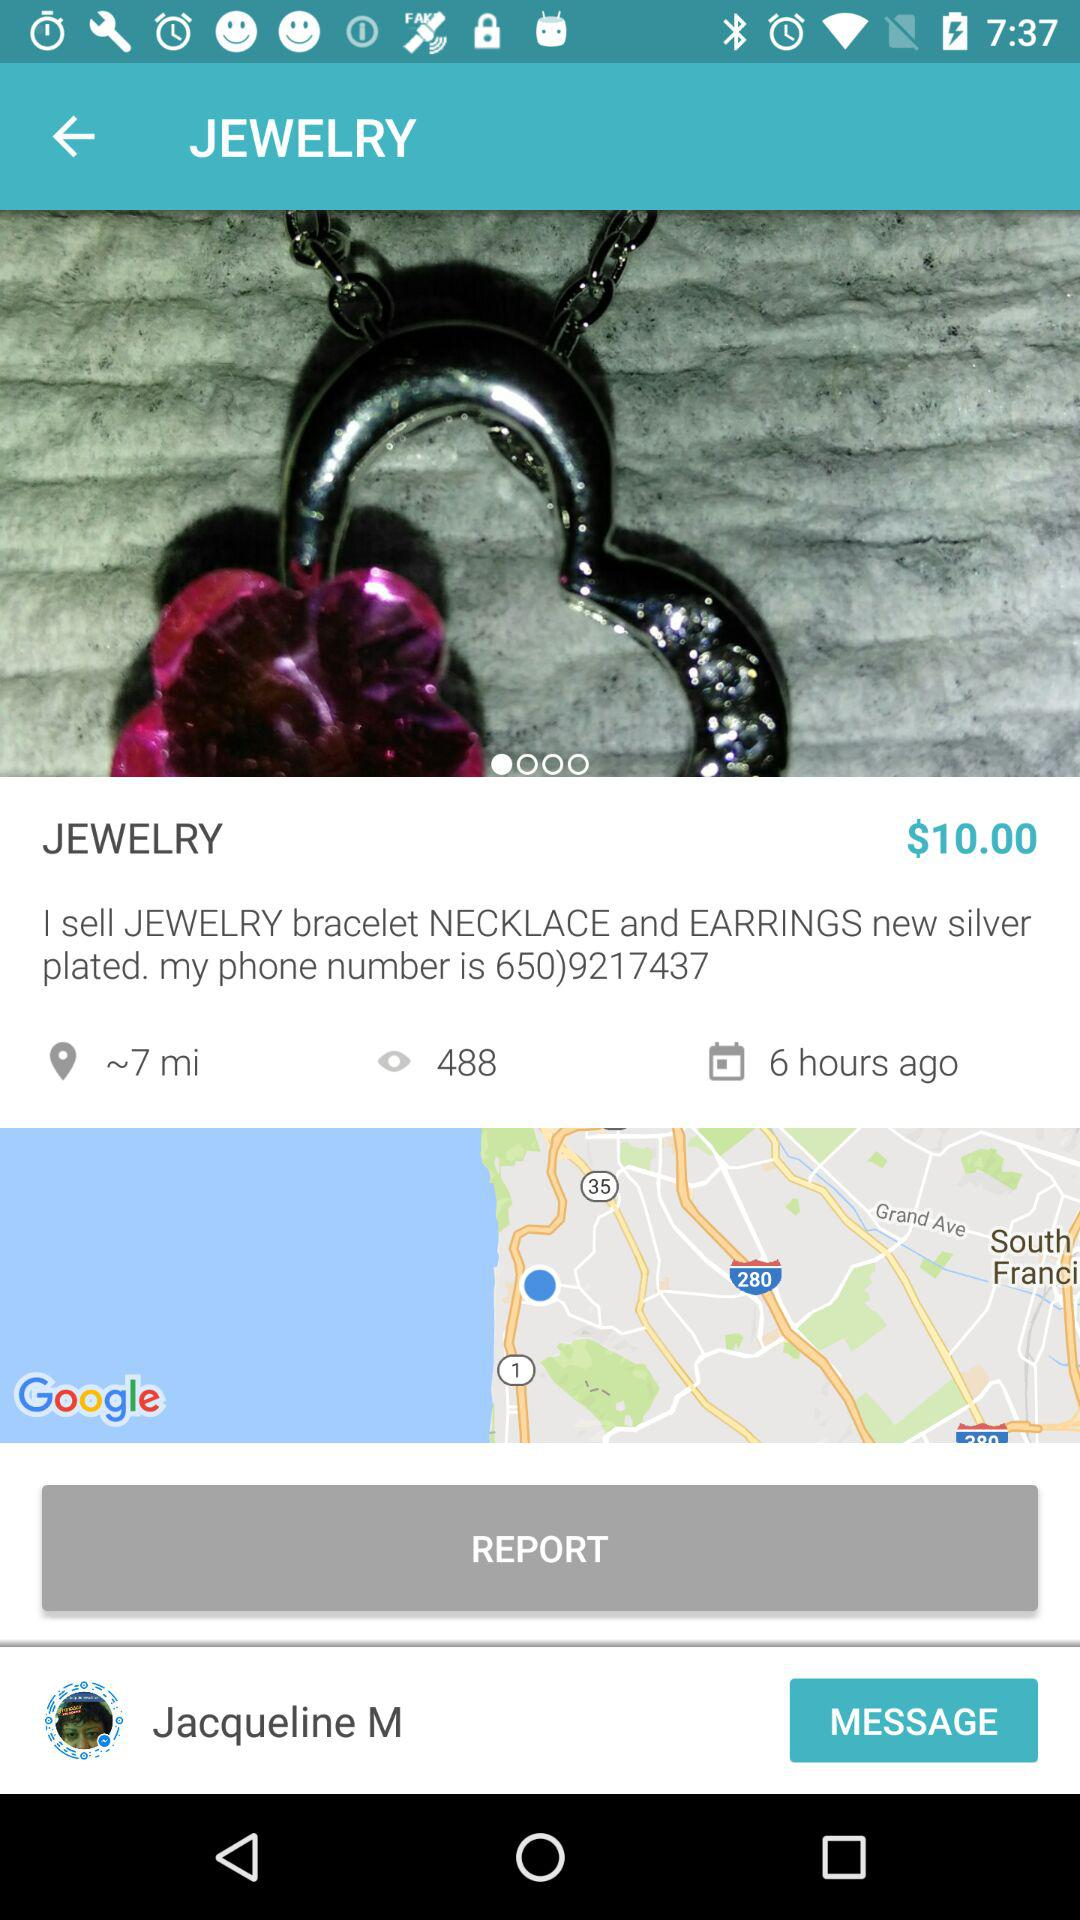What is the distance? The distance is approximately 7 miles. 